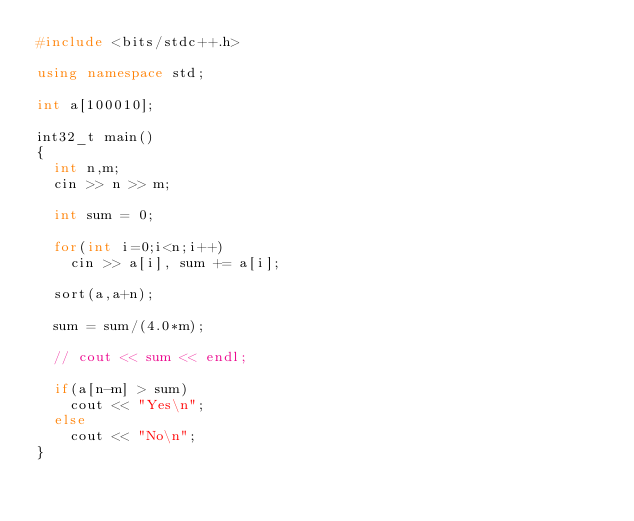<code> <loc_0><loc_0><loc_500><loc_500><_C++_>#include <bits/stdc++.h>

using namespace std;

int a[100010];

int32_t main()
{
	int n,m;
	cin >> n >> m;

	int sum = 0;

	for(int i=0;i<n;i++)
		cin >> a[i], sum += a[i];

	sort(a,a+n);

	sum = sum/(4.0*m);

	// cout << sum << endl;

	if(a[n-m] > sum)
		cout << "Yes\n";
	else
		cout << "No\n";
}</code> 